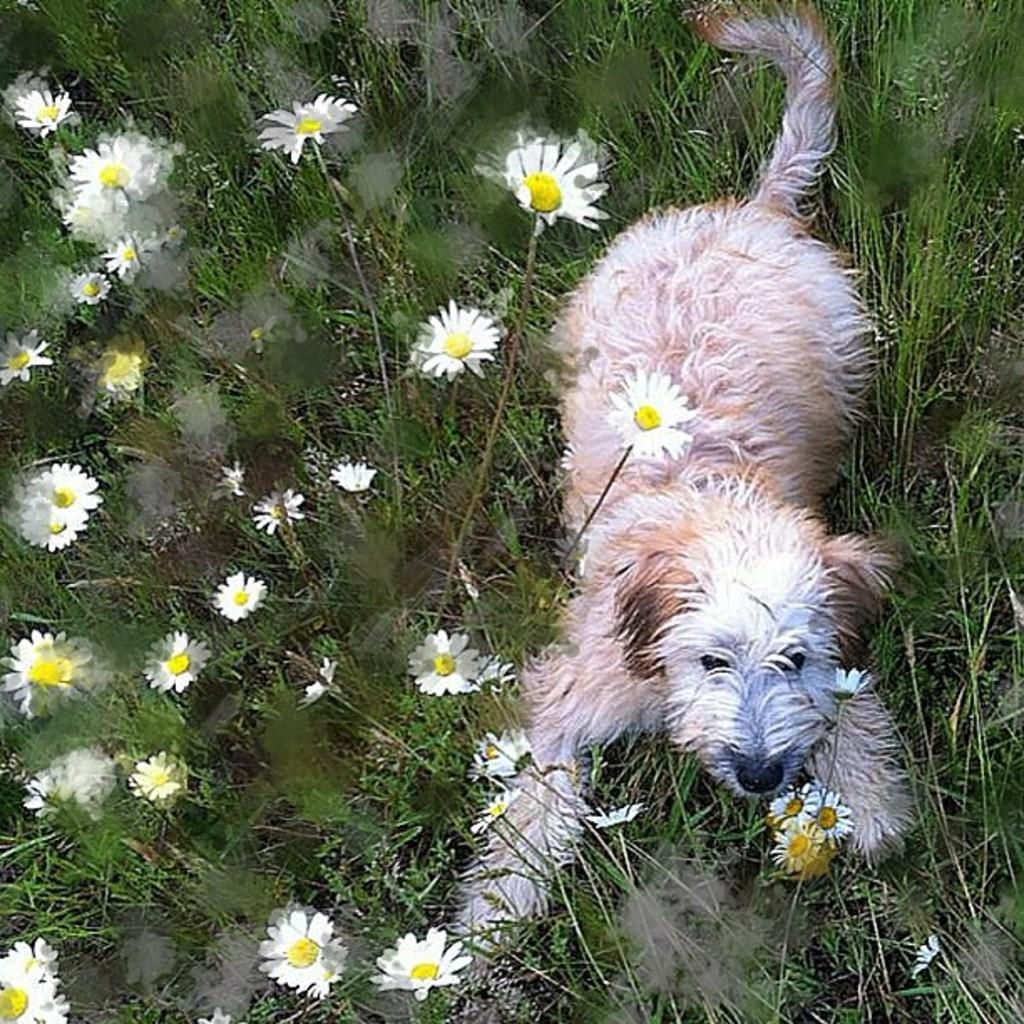What animal is present in the image? There is a dog in the image. Where is the dog located? The dog is sitting on the grass. What type of vegetation can be seen in the image? There are white color flowers in the image. What type of business is being conducted in the image? There is no indication of any business being conducted in the image; it primarily features a dog sitting on the grass and white color flowers. 